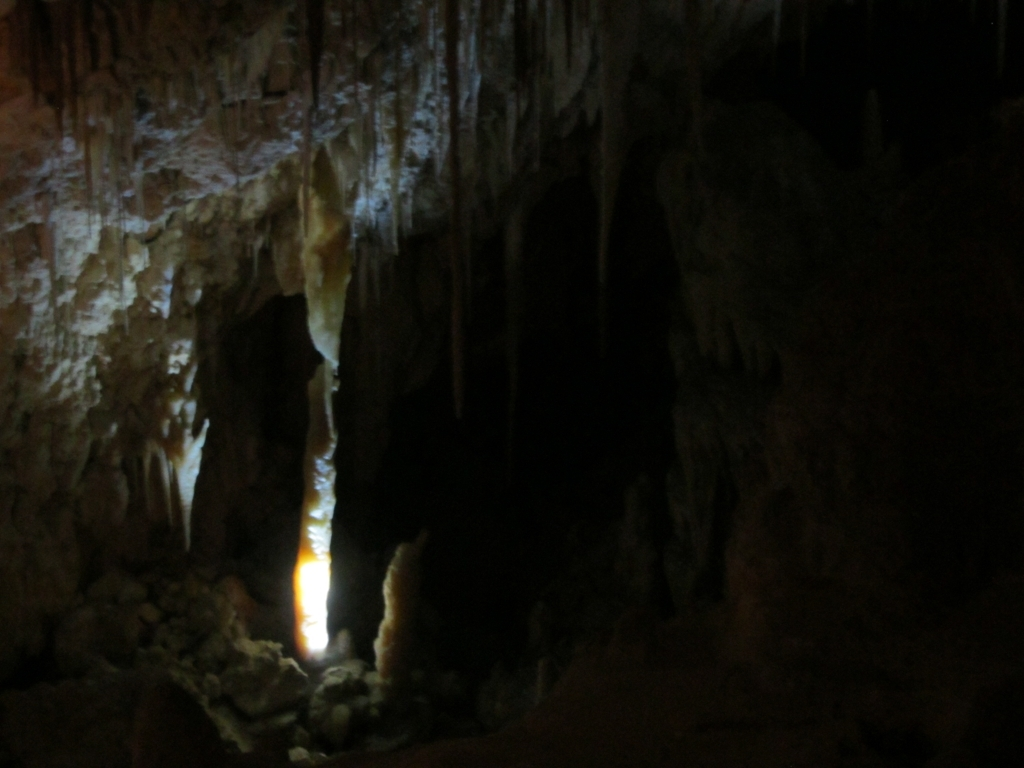What is the main issue with the lighting in this image?
A. Perfect lighting
B. Insufficient lighting
C. Excessive lighting
D. Natural lighting The main issue with the lighting in this image is insufficient lighting, denoted by option B. The image is quite dark, making it difficult to discern fine details. The lighting appears to be artificial, concentrated in a specific area, casting stark shadows and leaving much of the scene obscured. In photography terms, this could lead to an underexposed image, where the camera's sensor doesn't capture enough light to reveal textures and features in the darker areas. 